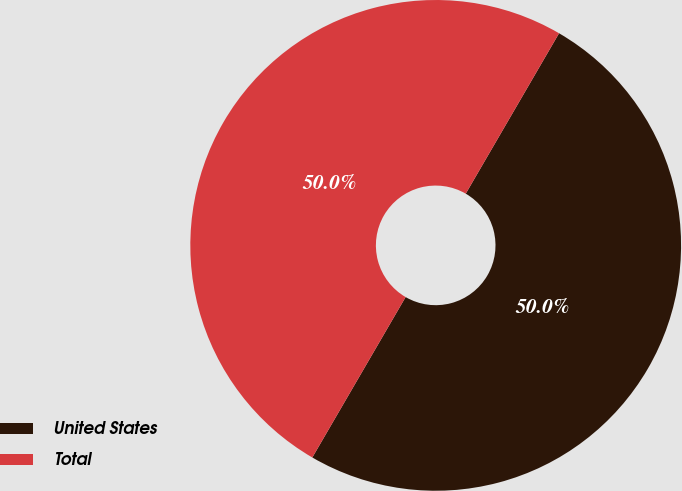Convert chart to OTSL. <chart><loc_0><loc_0><loc_500><loc_500><pie_chart><fcel>United States<fcel>Total<nl><fcel>50.0%<fcel>50.0%<nl></chart> 